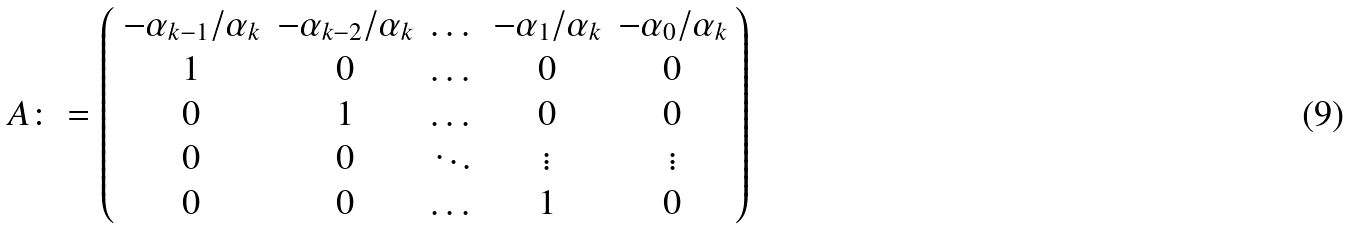<formula> <loc_0><loc_0><loc_500><loc_500>A \colon = \left ( \begin{array} { c c c c c } - \alpha _ { k - 1 } / \alpha _ { k } & - \alpha _ { k - 2 } / \alpha _ { k } & \dots & - \alpha _ { 1 } / \alpha _ { k } & - \alpha _ { 0 } / \alpha _ { k } \\ 1 & 0 & \dots & 0 & 0 \\ 0 & 1 & \dots & 0 & 0 \\ 0 & 0 & \ddots & \vdots & \vdots \\ 0 & 0 & \dots & 1 & 0 \\ \end{array} \right )</formula> 